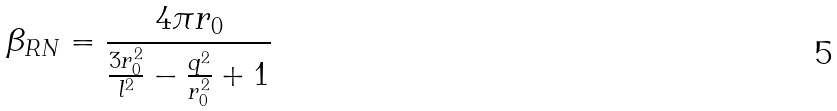Convert formula to latex. <formula><loc_0><loc_0><loc_500><loc_500>\beta _ { R N } = \frac { 4 \pi r _ { 0 } } { \frac { 3 r _ { 0 } ^ { 2 } } { l ^ { 2 } } - \frac { q ^ { 2 } } { r _ { 0 } ^ { 2 } } + 1 }</formula> 